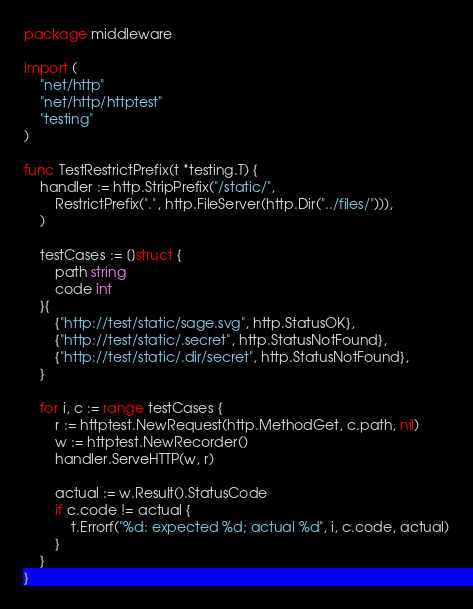<code> <loc_0><loc_0><loc_500><loc_500><_Go_>package middleware

import (
	"net/http"
	"net/http/httptest"
	"testing"
)

func TestRestrictPrefix(t *testing.T) {
	handler := http.StripPrefix("/static/",
		RestrictPrefix(".", http.FileServer(http.Dir("../files/"))),
	)

	testCases := []struct {
		path string
		code int
	}{
		{"http://test/static/sage.svg", http.StatusOK},
		{"http://test/static/.secret", http.StatusNotFound},
		{"http://test/static/.dir/secret", http.StatusNotFound},
	}

	for i, c := range testCases {
		r := httptest.NewRequest(http.MethodGet, c.path, nil)
		w := httptest.NewRecorder()
		handler.ServeHTTP(w, r)

		actual := w.Result().StatusCode
		if c.code != actual {
			t.Errorf("%d: expected %d; actual %d", i, c.code, actual)
		}
	}
}
</code> 